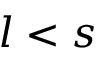<formula> <loc_0><loc_0><loc_500><loc_500>l < s</formula> 